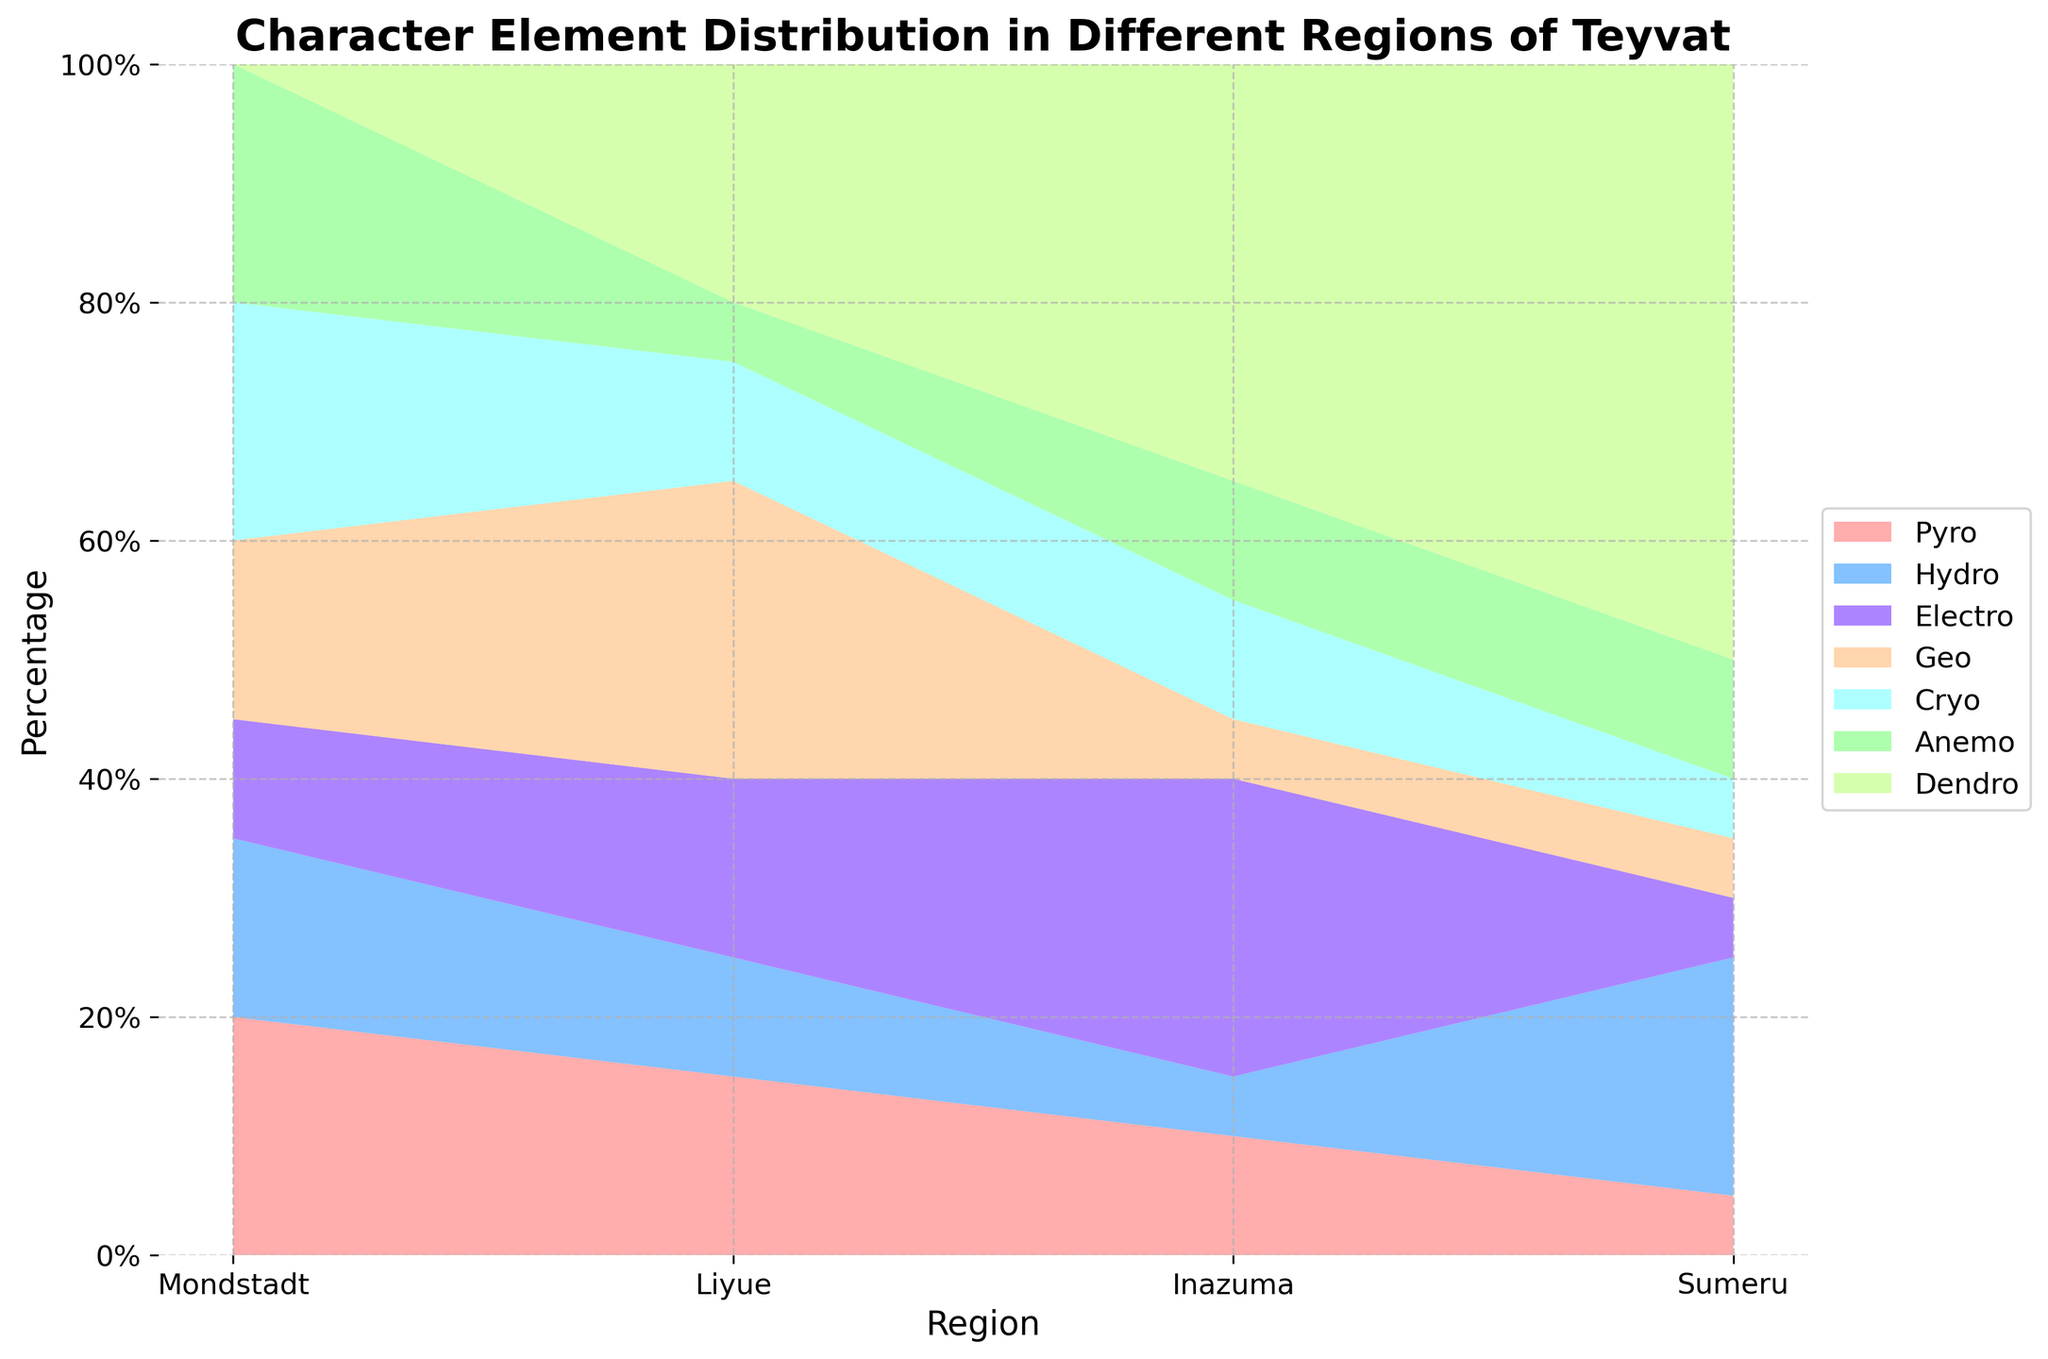What is the title of the figure? The title of the figure is typically located at the top and summarizes what the chart represents. It reads "Character Element Distribution in Different Regions of Teyvat".
Answer: Character Element Distribution in Different Regions of Teyvat How many regions are displayed in the chart? The x-axis of the chart lists the regions across which the data is distributed. By counting the distinct categories, we find there are four regions displayed.
Answer: Four Which element has the highest percentage in the Sumeru region? By observing the stacked areas for the Sumeru region and noting their relative sizes, the Dendro element reaches the highest on the vertical scale.
Answer: Dendro What is the overall trend for the Hydro element across the regions? Examining the band/area representing the Hydro element across all regions shows its relative size and position change. Starting from Mondstadt to Sumeru, Hydro's proportion varies but shows notable presence in Sumeru.
Answer: Varies, peaks at Sumeru Compare the percentage of the Pyro element between Mondstadt and Liyue. By examining the height of the Pyro section in both Mondstadt and Liyue, it appears larger for Mondstadt. This implies Mondstadt has a higher distribution of Pyro characters compared to Liyue.
Answer: Higher in Mondstadt Which region has the least Cryo characters? By looking at the height of the Cryo segment across all regions, Sumeru has the smallest segment for Cryo characters.
Answer: Sumeru Calculate the difference in the percentage of Geo characters between Liyue and Inazuma. By comparing the heights of the Geo segments, Liyue has a 25% share, and Inazuma has 5%. The difference is obtained by subtracting the smaller from the larger value: 25% - 5%.
Answer: 20% Which element is exclusive to a single region and which region is it? Observing the stacked areas indicates that the Dendro element is highly concentrated in Sumeru and is not present in other regions.
Answer: Dendro in Sumeru Analyze the trend of the Anemo element across all regions. Tracking the relative height of the Anemo segment from Mondstadt to Sumeru, it starts high in Mondstadt and dwindles in the subsequent regions.
Answer: Decreases across regions What is the sum of the percentage for Pyro, Cryo, and Geo elements in Inazuma? By summing up the individual percentages for these elements in Inazuma: Pyro (10%) + Cryo (10%) + Geo (5%) equals 25%.
Answer: 25% 